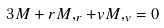Convert formula to latex. <formula><loc_0><loc_0><loc_500><loc_500>3 M + r M , _ { r } + v M , _ { v } = 0</formula> 